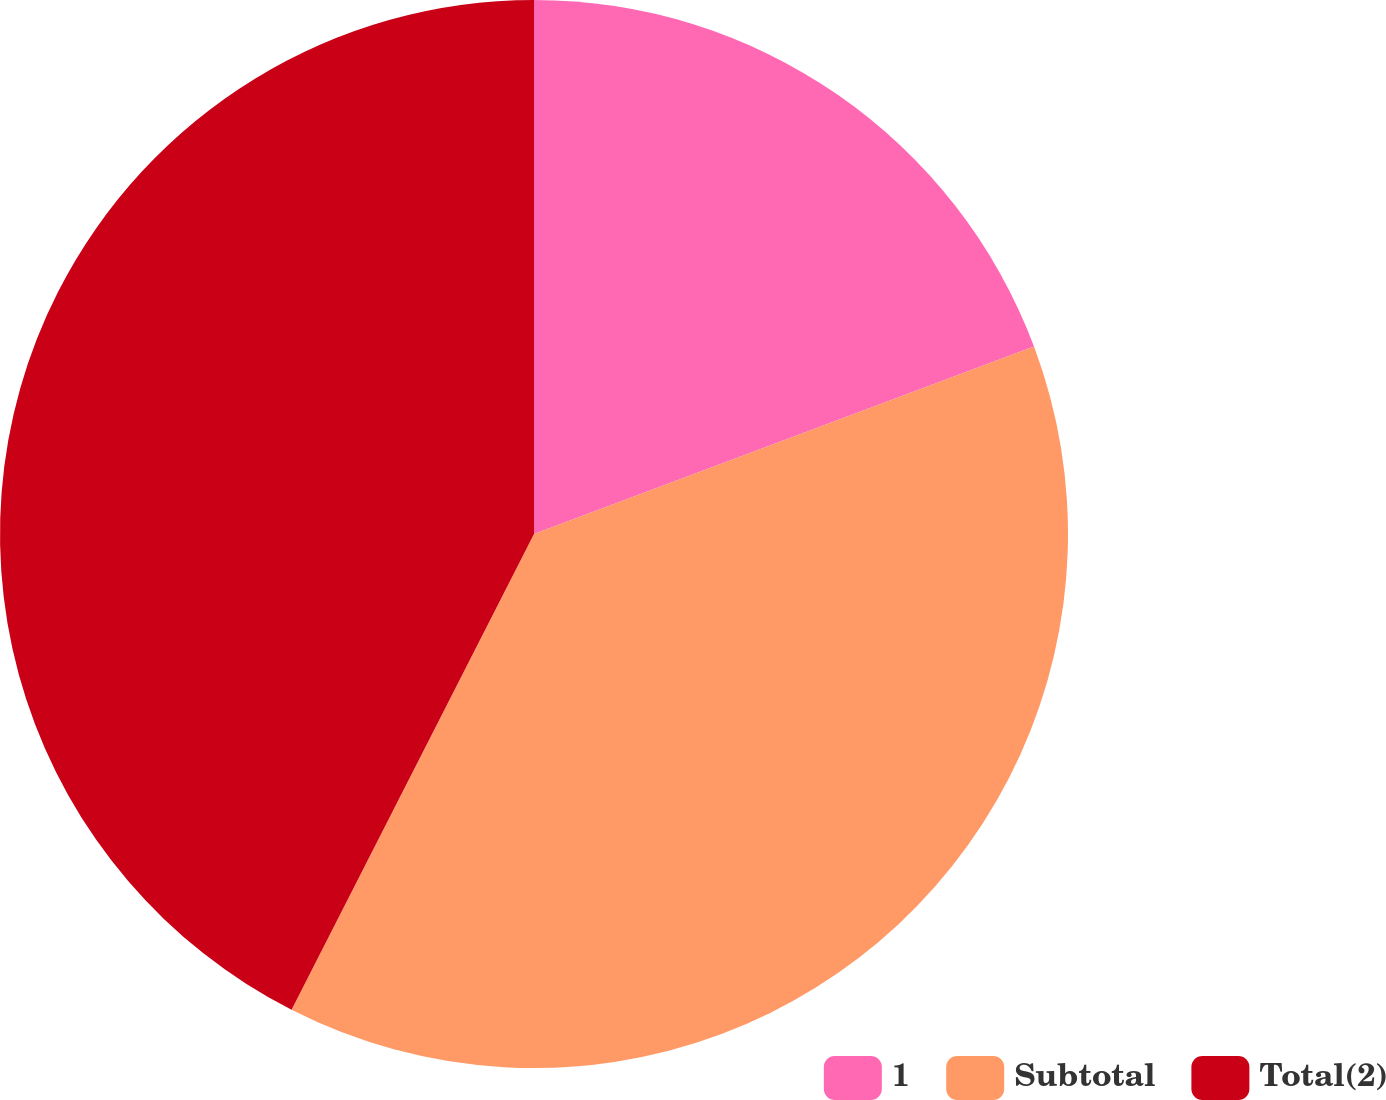Convert chart. <chart><loc_0><loc_0><loc_500><loc_500><pie_chart><fcel>1<fcel>Subtotal<fcel>Total(2)<nl><fcel>19.29%<fcel>38.21%<fcel>42.5%<nl></chart> 